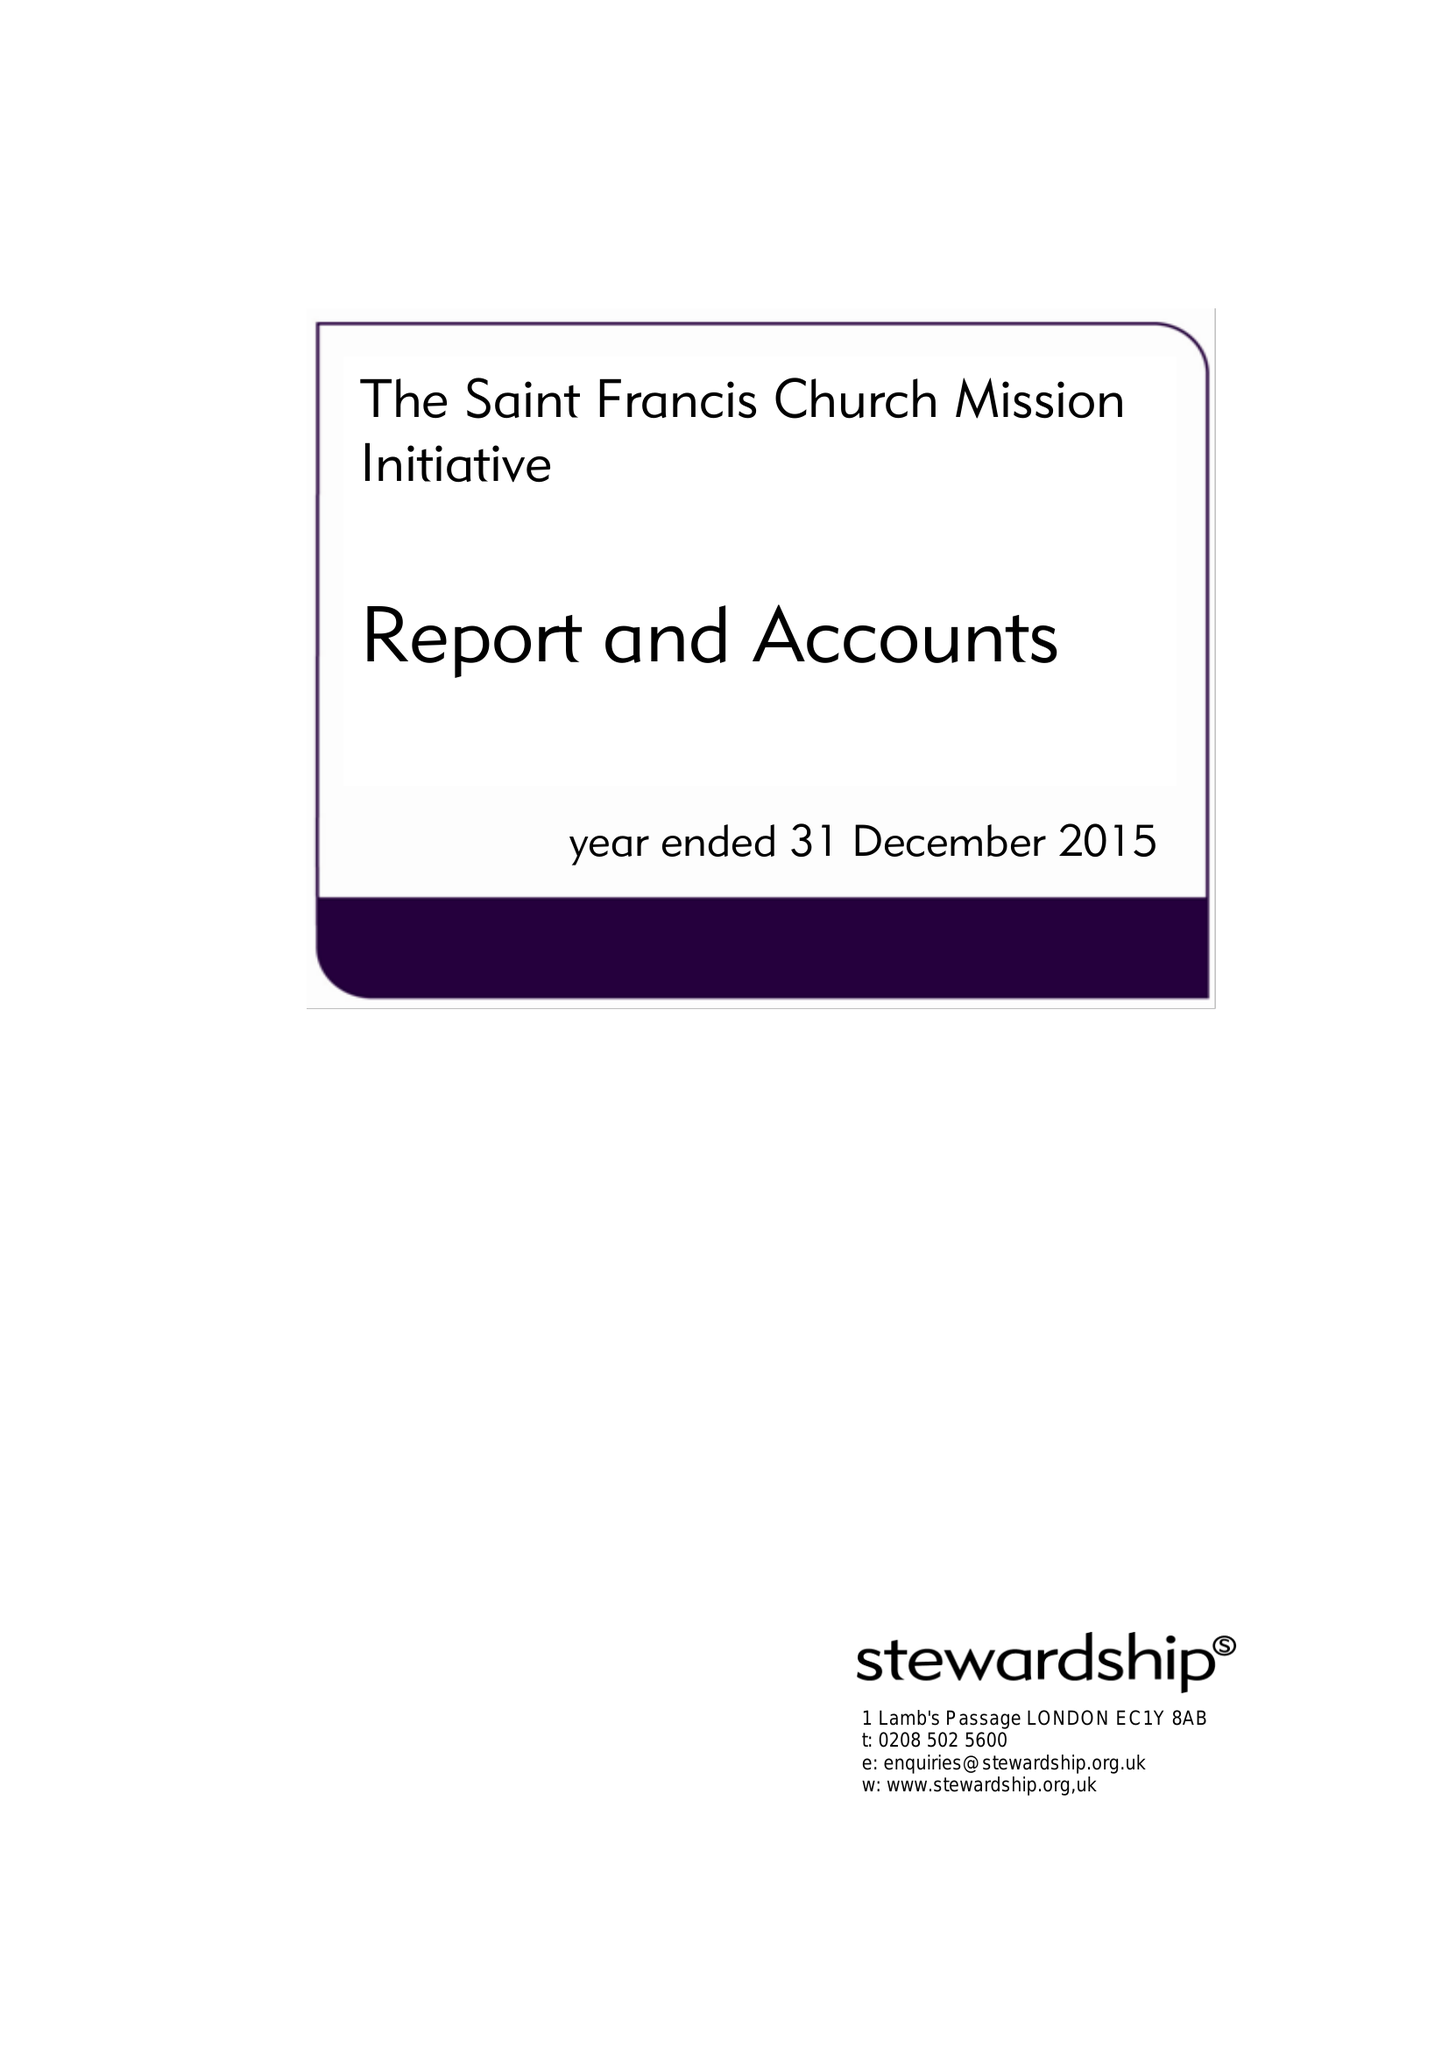What is the value for the spending_annually_in_british_pounds?
Answer the question using a single word or phrase. 114356.00 